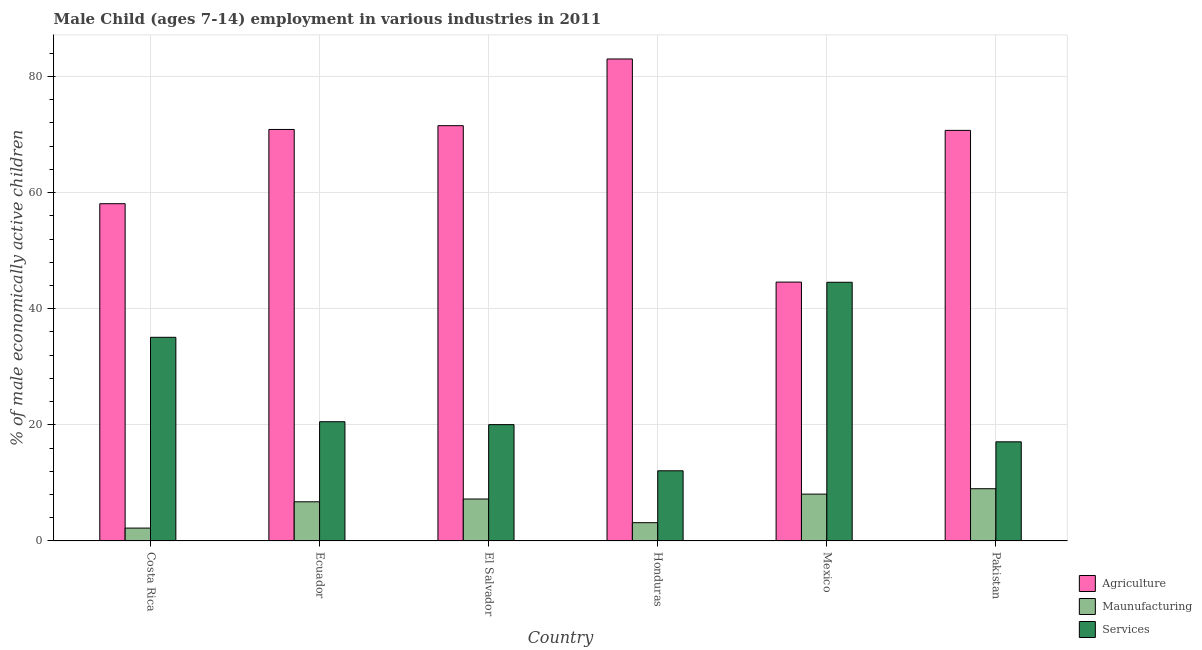How many different coloured bars are there?
Give a very brief answer. 3. How many groups of bars are there?
Your response must be concise. 6. Are the number of bars per tick equal to the number of legend labels?
Offer a terse response. Yes. How many bars are there on the 6th tick from the right?
Make the answer very short. 3. What is the label of the 5th group of bars from the left?
Your answer should be compact. Mexico. What is the percentage of economically active children in agriculture in Mexico?
Keep it short and to the point. 44.59. Across all countries, what is the maximum percentage of economically active children in agriculture?
Give a very brief answer. 83.02. Across all countries, what is the minimum percentage of economically active children in manufacturing?
Keep it short and to the point. 2.22. In which country was the percentage of economically active children in services minimum?
Offer a terse response. Honduras. What is the total percentage of economically active children in agriculture in the graph?
Your response must be concise. 398.83. What is the difference between the percentage of economically active children in agriculture in Honduras and that in Mexico?
Provide a succinct answer. 38.43. What is the difference between the percentage of economically active children in services in Costa Rica and the percentage of economically active children in agriculture in El Salvador?
Provide a short and direct response. -36.45. What is the average percentage of economically active children in agriculture per country?
Your response must be concise. 66.47. What is the difference between the percentage of economically active children in agriculture and percentage of economically active children in services in Mexico?
Give a very brief answer. 0.03. What is the ratio of the percentage of economically active children in agriculture in Ecuador to that in Pakistan?
Ensure brevity in your answer.  1. Is the percentage of economically active children in services in Ecuador less than that in Mexico?
Offer a very short reply. Yes. Is the difference between the percentage of economically active children in manufacturing in Ecuador and El Salvador greater than the difference between the percentage of economically active children in agriculture in Ecuador and El Salvador?
Make the answer very short. Yes. What is the difference between the highest and the second highest percentage of economically active children in agriculture?
Provide a short and direct response. 11.49. What is the difference between the highest and the lowest percentage of economically active children in services?
Your answer should be compact. 32.47. In how many countries, is the percentage of economically active children in agriculture greater than the average percentage of economically active children in agriculture taken over all countries?
Give a very brief answer. 4. Is the sum of the percentage of economically active children in services in Ecuador and Pakistan greater than the maximum percentage of economically active children in manufacturing across all countries?
Provide a short and direct response. Yes. What does the 2nd bar from the left in Ecuador represents?
Provide a succinct answer. Maunufacturing. What does the 1st bar from the right in Pakistan represents?
Your response must be concise. Services. Are all the bars in the graph horizontal?
Offer a very short reply. No. Are the values on the major ticks of Y-axis written in scientific E-notation?
Keep it short and to the point. No. Does the graph contain any zero values?
Offer a terse response. No. How are the legend labels stacked?
Provide a short and direct response. Vertical. What is the title of the graph?
Keep it short and to the point. Male Child (ages 7-14) employment in various industries in 2011. Does "Ages 0-14" appear as one of the legend labels in the graph?
Offer a very short reply. No. What is the label or title of the X-axis?
Your answer should be compact. Country. What is the label or title of the Y-axis?
Offer a very short reply. % of male economically active children. What is the % of male economically active children in Agriculture in Costa Rica?
Provide a short and direct response. 58.09. What is the % of male economically active children in Maunufacturing in Costa Rica?
Your answer should be compact. 2.22. What is the % of male economically active children of Services in Costa Rica?
Offer a terse response. 35.08. What is the % of male economically active children of Agriculture in Ecuador?
Offer a terse response. 70.88. What is the % of male economically active children of Maunufacturing in Ecuador?
Your response must be concise. 6.75. What is the % of male economically active children in Services in Ecuador?
Your answer should be very brief. 20.54. What is the % of male economically active children in Agriculture in El Salvador?
Your answer should be compact. 71.53. What is the % of male economically active children in Maunufacturing in El Salvador?
Make the answer very short. 7.23. What is the % of male economically active children in Services in El Salvador?
Ensure brevity in your answer.  20.04. What is the % of male economically active children of Agriculture in Honduras?
Provide a succinct answer. 83.02. What is the % of male economically active children of Maunufacturing in Honduras?
Ensure brevity in your answer.  3.15. What is the % of male economically active children of Services in Honduras?
Your response must be concise. 12.09. What is the % of male economically active children of Agriculture in Mexico?
Ensure brevity in your answer.  44.59. What is the % of male economically active children in Maunufacturing in Mexico?
Keep it short and to the point. 8.07. What is the % of male economically active children in Services in Mexico?
Make the answer very short. 44.56. What is the % of male economically active children in Agriculture in Pakistan?
Provide a short and direct response. 70.72. What is the % of male economically active children in Maunufacturing in Pakistan?
Provide a short and direct response. 9. What is the % of male economically active children of Services in Pakistan?
Your response must be concise. 17.08. Across all countries, what is the maximum % of male economically active children of Agriculture?
Make the answer very short. 83.02. Across all countries, what is the maximum % of male economically active children in Maunufacturing?
Your answer should be compact. 9. Across all countries, what is the maximum % of male economically active children in Services?
Your response must be concise. 44.56. Across all countries, what is the minimum % of male economically active children in Agriculture?
Provide a succinct answer. 44.59. Across all countries, what is the minimum % of male economically active children in Maunufacturing?
Offer a terse response. 2.22. Across all countries, what is the minimum % of male economically active children in Services?
Provide a succinct answer. 12.09. What is the total % of male economically active children of Agriculture in the graph?
Provide a short and direct response. 398.83. What is the total % of male economically active children of Maunufacturing in the graph?
Ensure brevity in your answer.  36.42. What is the total % of male economically active children in Services in the graph?
Give a very brief answer. 149.39. What is the difference between the % of male economically active children of Agriculture in Costa Rica and that in Ecuador?
Ensure brevity in your answer.  -12.79. What is the difference between the % of male economically active children in Maunufacturing in Costa Rica and that in Ecuador?
Make the answer very short. -4.53. What is the difference between the % of male economically active children of Services in Costa Rica and that in Ecuador?
Offer a very short reply. 14.54. What is the difference between the % of male economically active children of Agriculture in Costa Rica and that in El Salvador?
Make the answer very short. -13.44. What is the difference between the % of male economically active children of Maunufacturing in Costa Rica and that in El Salvador?
Offer a terse response. -5.01. What is the difference between the % of male economically active children in Services in Costa Rica and that in El Salvador?
Ensure brevity in your answer.  15.04. What is the difference between the % of male economically active children of Agriculture in Costa Rica and that in Honduras?
Your response must be concise. -24.93. What is the difference between the % of male economically active children in Maunufacturing in Costa Rica and that in Honduras?
Your response must be concise. -0.93. What is the difference between the % of male economically active children of Services in Costa Rica and that in Honduras?
Provide a succinct answer. 22.99. What is the difference between the % of male economically active children in Agriculture in Costa Rica and that in Mexico?
Your answer should be compact. 13.5. What is the difference between the % of male economically active children of Maunufacturing in Costa Rica and that in Mexico?
Offer a terse response. -5.85. What is the difference between the % of male economically active children in Services in Costa Rica and that in Mexico?
Give a very brief answer. -9.48. What is the difference between the % of male economically active children in Agriculture in Costa Rica and that in Pakistan?
Ensure brevity in your answer.  -12.63. What is the difference between the % of male economically active children of Maunufacturing in Costa Rica and that in Pakistan?
Your answer should be very brief. -6.78. What is the difference between the % of male economically active children in Services in Costa Rica and that in Pakistan?
Your answer should be compact. 18. What is the difference between the % of male economically active children of Agriculture in Ecuador and that in El Salvador?
Your answer should be compact. -0.65. What is the difference between the % of male economically active children of Maunufacturing in Ecuador and that in El Salvador?
Your response must be concise. -0.48. What is the difference between the % of male economically active children of Services in Ecuador and that in El Salvador?
Your response must be concise. 0.5. What is the difference between the % of male economically active children in Agriculture in Ecuador and that in Honduras?
Provide a short and direct response. -12.14. What is the difference between the % of male economically active children of Services in Ecuador and that in Honduras?
Your answer should be very brief. 8.45. What is the difference between the % of male economically active children of Agriculture in Ecuador and that in Mexico?
Make the answer very short. 26.29. What is the difference between the % of male economically active children of Maunufacturing in Ecuador and that in Mexico?
Keep it short and to the point. -1.32. What is the difference between the % of male economically active children in Services in Ecuador and that in Mexico?
Ensure brevity in your answer.  -24.02. What is the difference between the % of male economically active children in Agriculture in Ecuador and that in Pakistan?
Your response must be concise. 0.16. What is the difference between the % of male economically active children in Maunufacturing in Ecuador and that in Pakistan?
Provide a short and direct response. -2.25. What is the difference between the % of male economically active children in Services in Ecuador and that in Pakistan?
Offer a very short reply. 3.46. What is the difference between the % of male economically active children of Agriculture in El Salvador and that in Honduras?
Offer a very short reply. -11.49. What is the difference between the % of male economically active children of Maunufacturing in El Salvador and that in Honduras?
Your answer should be compact. 4.08. What is the difference between the % of male economically active children of Services in El Salvador and that in Honduras?
Offer a terse response. 7.95. What is the difference between the % of male economically active children of Agriculture in El Salvador and that in Mexico?
Give a very brief answer. 26.94. What is the difference between the % of male economically active children in Maunufacturing in El Salvador and that in Mexico?
Offer a terse response. -0.84. What is the difference between the % of male economically active children in Services in El Salvador and that in Mexico?
Make the answer very short. -24.52. What is the difference between the % of male economically active children of Agriculture in El Salvador and that in Pakistan?
Offer a terse response. 0.81. What is the difference between the % of male economically active children of Maunufacturing in El Salvador and that in Pakistan?
Your answer should be compact. -1.77. What is the difference between the % of male economically active children in Services in El Salvador and that in Pakistan?
Provide a short and direct response. 2.96. What is the difference between the % of male economically active children in Agriculture in Honduras and that in Mexico?
Your response must be concise. 38.43. What is the difference between the % of male economically active children of Maunufacturing in Honduras and that in Mexico?
Offer a terse response. -4.92. What is the difference between the % of male economically active children of Services in Honduras and that in Mexico?
Provide a succinct answer. -32.47. What is the difference between the % of male economically active children of Agriculture in Honduras and that in Pakistan?
Keep it short and to the point. 12.3. What is the difference between the % of male economically active children in Maunufacturing in Honduras and that in Pakistan?
Give a very brief answer. -5.85. What is the difference between the % of male economically active children of Services in Honduras and that in Pakistan?
Provide a succinct answer. -4.99. What is the difference between the % of male economically active children of Agriculture in Mexico and that in Pakistan?
Give a very brief answer. -26.13. What is the difference between the % of male economically active children in Maunufacturing in Mexico and that in Pakistan?
Offer a terse response. -0.93. What is the difference between the % of male economically active children of Services in Mexico and that in Pakistan?
Your answer should be very brief. 27.48. What is the difference between the % of male economically active children in Agriculture in Costa Rica and the % of male economically active children in Maunufacturing in Ecuador?
Your answer should be compact. 51.34. What is the difference between the % of male economically active children of Agriculture in Costa Rica and the % of male economically active children of Services in Ecuador?
Offer a very short reply. 37.55. What is the difference between the % of male economically active children of Maunufacturing in Costa Rica and the % of male economically active children of Services in Ecuador?
Ensure brevity in your answer.  -18.32. What is the difference between the % of male economically active children of Agriculture in Costa Rica and the % of male economically active children of Maunufacturing in El Salvador?
Provide a succinct answer. 50.86. What is the difference between the % of male economically active children of Agriculture in Costa Rica and the % of male economically active children of Services in El Salvador?
Give a very brief answer. 38.05. What is the difference between the % of male economically active children in Maunufacturing in Costa Rica and the % of male economically active children in Services in El Salvador?
Offer a terse response. -17.82. What is the difference between the % of male economically active children of Agriculture in Costa Rica and the % of male economically active children of Maunufacturing in Honduras?
Keep it short and to the point. 54.94. What is the difference between the % of male economically active children of Maunufacturing in Costa Rica and the % of male economically active children of Services in Honduras?
Make the answer very short. -9.87. What is the difference between the % of male economically active children in Agriculture in Costa Rica and the % of male economically active children in Maunufacturing in Mexico?
Keep it short and to the point. 50.02. What is the difference between the % of male economically active children of Agriculture in Costa Rica and the % of male economically active children of Services in Mexico?
Make the answer very short. 13.53. What is the difference between the % of male economically active children in Maunufacturing in Costa Rica and the % of male economically active children in Services in Mexico?
Offer a very short reply. -42.34. What is the difference between the % of male economically active children of Agriculture in Costa Rica and the % of male economically active children of Maunufacturing in Pakistan?
Your answer should be very brief. 49.09. What is the difference between the % of male economically active children of Agriculture in Costa Rica and the % of male economically active children of Services in Pakistan?
Your answer should be very brief. 41.01. What is the difference between the % of male economically active children of Maunufacturing in Costa Rica and the % of male economically active children of Services in Pakistan?
Offer a terse response. -14.86. What is the difference between the % of male economically active children in Agriculture in Ecuador and the % of male economically active children in Maunufacturing in El Salvador?
Make the answer very short. 63.65. What is the difference between the % of male economically active children of Agriculture in Ecuador and the % of male economically active children of Services in El Salvador?
Keep it short and to the point. 50.84. What is the difference between the % of male economically active children of Maunufacturing in Ecuador and the % of male economically active children of Services in El Salvador?
Provide a succinct answer. -13.29. What is the difference between the % of male economically active children of Agriculture in Ecuador and the % of male economically active children of Maunufacturing in Honduras?
Keep it short and to the point. 67.73. What is the difference between the % of male economically active children of Agriculture in Ecuador and the % of male economically active children of Services in Honduras?
Provide a short and direct response. 58.79. What is the difference between the % of male economically active children in Maunufacturing in Ecuador and the % of male economically active children in Services in Honduras?
Offer a very short reply. -5.34. What is the difference between the % of male economically active children of Agriculture in Ecuador and the % of male economically active children of Maunufacturing in Mexico?
Give a very brief answer. 62.81. What is the difference between the % of male economically active children of Agriculture in Ecuador and the % of male economically active children of Services in Mexico?
Offer a terse response. 26.32. What is the difference between the % of male economically active children of Maunufacturing in Ecuador and the % of male economically active children of Services in Mexico?
Give a very brief answer. -37.81. What is the difference between the % of male economically active children in Agriculture in Ecuador and the % of male economically active children in Maunufacturing in Pakistan?
Offer a very short reply. 61.88. What is the difference between the % of male economically active children of Agriculture in Ecuador and the % of male economically active children of Services in Pakistan?
Your answer should be compact. 53.8. What is the difference between the % of male economically active children in Maunufacturing in Ecuador and the % of male economically active children in Services in Pakistan?
Give a very brief answer. -10.33. What is the difference between the % of male economically active children in Agriculture in El Salvador and the % of male economically active children in Maunufacturing in Honduras?
Provide a succinct answer. 68.38. What is the difference between the % of male economically active children in Agriculture in El Salvador and the % of male economically active children in Services in Honduras?
Your answer should be very brief. 59.44. What is the difference between the % of male economically active children of Maunufacturing in El Salvador and the % of male economically active children of Services in Honduras?
Give a very brief answer. -4.86. What is the difference between the % of male economically active children of Agriculture in El Salvador and the % of male economically active children of Maunufacturing in Mexico?
Make the answer very short. 63.46. What is the difference between the % of male economically active children of Agriculture in El Salvador and the % of male economically active children of Services in Mexico?
Offer a very short reply. 26.97. What is the difference between the % of male economically active children of Maunufacturing in El Salvador and the % of male economically active children of Services in Mexico?
Ensure brevity in your answer.  -37.33. What is the difference between the % of male economically active children in Agriculture in El Salvador and the % of male economically active children in Maunufacturing in Pakistan?
Keep it short and to the point. 62.53. What is the difference between the % of male economically active children in Agriculture in El Salvador and the % of male economically active children in Services in Pakistan?
Provide a short and direct response. 54.45. What is the difference between the % of male economically active children of Maunufacturing in El Salvador and the % of male economically active children of Services in Pakistan?
Provide a succinct answer. -9.85. What is the difference between the % of male economically active children in Agriculture in Honduras and the % of male economically active children in Maunufacturing in Mexico?
Your answer should be compact. 74.95. What is the difference between the % of male economically active children of Agriculture in Honduras and the % of male economically active children of Services in Mexico?
Provide a succinct answer. 38.46. What is the difference between the % of male economically active children of Maunufacturing in Honduras and the % of male economically active children of Services in Mexico?
Your answer should be compact. -41.41. What is the difference between the % of male economically active children of Agriculture in Honduras and the % of male economically active children of Maunufacturing in Pakistan?
Offer a terse response. 74.02. What is the difference between the % of male economically active children of Agriculture in Honduras and the % of male economically active children of Services in Pakistan?
Ensure brevity in your answer.  65.94. What is the difference between the % of male economically active children of Maunufacturing in Honduras and the % of male economically active children of Services in Pakistan?
Offer a very short reply. -13.93. What is the difference between the % of male economically active children in Agriculture in Mexico and the % of male economically active children in Maunufacturing in Pakistan?
Your answer should be very brief. 35.59. What is the difference between the % of male economically active children in Agriculture in Mexico and the % of male economically active children in Services in Pakistan?
Make the answer very short. 27.51. What is the difference between the % of male economically active children in Maunufacturing in Mexico and the % of male economically active children in Services in Pakistan?
Provide a succinct answer. -9.01. What is the average % of male economically active children in Agriculture per country?
Keep it short and to the point. 66.47. What is the average % of male economically active children of Maunufacturing per country?
Ensure brevity in your answer.  6.07. What is the average % of male economically active children in Services per country?
Give a very brief answer. 24.9. What is the difference between the % of male economically active children of Agriculture and % of male economically active children of Maunufacturing in Costa Rica?
Your response must be concise. 55.87. What is the difference between the % of male economically active children of Agriculture and % of male economically active children of Services in Costa Rica?
Ensure brevity in your answer.  23.01. What is the difference between the % of male economically active children in Maunufacturing and % of male economically active children in Services in Costa Rica?
Offer a terse response. -32.86. What is the difference between the % of male economically active children in Agriculture and % of male economically active children in Maunufacturing in Ecuador?
Make the answer very short. 64.13. What is the difference between the % of male economically active children in Agriculture and % of male economically active children in Services in Ecuador?
Offer a very short reply. 50.34. What is the difference between the % of male economically active children in Maunufacturing and % of male economically active children in Services in Ecuador?
Ensure brevity in your answer.  -13.79. What is the difference between the % of male economically active children in Agriculture and % of male economically active children in Maunufacturing in El Salvador?
Your answer should be compact. 64.3. What is the difference between the % of male economically active children of Agriculture and % of male economically active children of Services in El Salvador?
Provide a succinct answer. 51.49. What is the difference between the % of male economically active children of Maunufacturing and % of male economically active children of Services in El Salvador?
Your answer should be compact. -12.81. What is the difference between the % of male economically active children in Agriculture and % of male economically active children in Maunufacturing in Honduras?
Give a very brief answer. 79.87. What is the difference between the % of male economically active children of Agriculture and % of male economically active children of Services in Honduras?
Offer a terse response. 70.93. What is the difference between the % of male economically active children in Maunufacturing and % of male economically active children in Services in Honduras?
Offer a very short reply. -8.94. What is the difference between the % of male economically active children in Agriculture and % of male economically active children in Maunufacturing in Mexico?
Your answer should be very brief. 36.52. What is the difference between the % of male economically active children of Agriculture and % of male economically active children of Services in Mexico?
Keep it short and to the point. 0.03. What is the difference between the % of male economically active children in Maunufacturing and % of male economically active children in Services in Mexico?
Offer a terse response. -36.49. What is the difference between the % of male economically active children in Agriculture and % of male economically active children in Maunufacturing in Pakistan?
Make the answer very short. 61.72. What is the difference between the % of male economically active children in Agriculture and % of male economically active children in Services in Pakistan?
Offer a terse response. 53.64. What is the difference between the % of male economically active children of Maunufacturing and % of male economically active children of Services in Pakistan?
Keep it short and to the point. -8.08. What is the ratio of the % of male economically active children in Agriculture in Costa Rica to that in Ecuador?
Give a very brief answer. 0.82. What is the ratio of the % of male economically active children in Maunufacturing in Costa Rica to that in Ecuador?
Offer a terse response. 0.33. What is the ratio of the % of male economically active children of Services in Costa Rica to that in Ecuador?
Offer a very short reply. 1.71. What is the ratio of the % of male economically active children of Agriculture in Costa Rica to that in El Salvador?
Your answer should be very brief. 0.81. What is the ratio of the % of male economically active children of Maunufacturing in Costa Rica to that in El Salvador?
Make the answer very short. 0.31. What is the ratio of the % of male economically active children in Services in Costa Rica to that in El Salvador?
Offer a terse response. 1.75. What is the ratio of the % of male economically active children in Agriculture in Costa Rica to that in Honduras?
Keep it short and to the point. 0.7. What is the ratio of the % of male economically active children in Maunufacturing in Costa Rica to that in Honduras?
Offer a very short reply. 0.7. What is the ratio of the % of male economically active children in Services in Costa Rica to that in Honduras?
Provide a succinct answer. 2.9. What is the ratio of the % of male economically active children in Agriculture in Costa Rica to that in Mexico?
Provide a short and direct response. 1.3. What is the ratio of the % of male economically active children in Maunufacturing in Costa Rica to that in Mexico?
Provide a short and direct response. 0.28. What is the ratio of the % of male economically active children of Services in Costa Rica to that in Mexico?
Keep it short and to the point. 0.79. What is the ratio of the % of male economically active children of Agriculture in Costa Rica to that in Pakistan?
Your answer should be compact. 0.82. What is the ratio of the % of male economically active children of Maunufacturing in Costa Rica to that in Pakistan?
Provide a short and direct response. 0.25. What is the ratio of the % of male economically active children of Services in Costa Rica to that in Pakistan?
Provide a succinct answer. 2.05. What is the ratio of the % of male economically active children of Agriculture in Ecuador to that in El Salvador?
Give a very brief answer. 0.99. What is the ratio of the % of male economically active children in Maunufacturing in Ecuador to that in El Salvador?
Your answer should be compact. 0.93. What is the ratio of the % of male economically active children of Services in Ecuador to that in El Salvador?
Offer a very short reply. 1.02. What is the ratio of the % of male economically active children of Agriculture in Ecuador to that in Honduras?
Offer a terse response. 0.85. What is the ratio of the % of male economically active children in Maunufacturing in Ecuador to that in Honduras?
Ensure brevity in your answer.  2.14. What is the ratio of the % of male economically active children in Services in Ecuador to that in Honduras?
Offer a very short reply. 1.7. What is the ratio of the % of male economically active children of Agriculture in Ecuador to that in Mexico?
Keep it short and to the point. 1.59. What is the ratio of the % of male economically active children in Maunufacturing in Ecuador to that in Mexico?
Give a very brief answer. 0.84. What is the ratio of the % of male economically active children of Services in Ecuador to that in Mexico?
Keep it short and to the point. 0.46. What is the ratio of the % of male economically active children in Agriculture in Ecuador to that in Pakistan?
Your answer should be compact. 1. What is the ratio of the % of male economically active children of Maunufacturing in Ecuador to that in Pakistan?
Your answer should be compact. 0.75. What is the ratio of the % of male economically active children in Services in Ecuador to that in Pakistan?
Provide a short and direct response. 1.2. What is the ratio of the % of male economically active children of Agriculture in El Salvador to that in Honduras?
Provide a short and direct response. 0.86. What is the ratio of the % of male economically active children in Maunufacturing in El Salvador to that in Honduras?
Keep it short and to the point. 2.3. What is the ratio of the % of male economically active children in Services in El Salvador to that in Honduras?
Your answer should be very brief. 1.66. What is the ratio of the % of male economically active children in Agriculture in El Salvador to that in Mexico?
Offer a terse response. 1.6. What is the ratio of the % of male economically active children in Maunufacturing in El Salvador to that in Mexico?
Provide a short and direct response. 0.9. What is the ratio of the % of male economically active children of Services in El Salvador to that in Mexico?
Give a very brief answer. 0.45. What is the ratio of the % of male economically active children of Agriculture in El Salvador to that in Pakistan?
Offer a terse response. 1.01. What is the ratio of the % of male economically active children of Maunufacturing in El Salvador to that in Pakistan?
Provide a short and direct response. 0.8. What is the ratio of the % of male economically active children in Services in El Salvador to that in Pakistan?
Keep it short and to the point. 1.17. What is the ratio of the % of male economically active children of Agriculture in Honduras to that in Mexico?
Your response must be concise. 1.86. What is the ratio of the % of male economically active children in Maunufacturing in Honduras to that in Mexico?
Make the answer very short. 0.39. What is the ratio of the % of male economically active children in Services in Honduras to that in Mexico?
Offer a very short reply. 0.27. What is the ratio of the % of male economically active children of Agriculture in Honduras to that in Pakistan?
Your answer should be very brief. 1.17. What is the ratio of the % of male economically active children in Maunufacturing in Honduras to that in Pakistan?
Ensure brevity in your answer.  0.35. What is the ratio of the % of male economically active children in Services in Honduras to that in Pakistan?
Keep it short and to the point. 0.71. What is the ratio of the % of male economically active children in Agriculture in Mexico to that in Pakistan?
Your answer should be compact. 0.63. What is the ratio of the % of male economically active children in Maunufacturing in Mexico to that in Pakistan?
Your response must be concise. 0.9. What is the ratio of the % of male economically active children of Services in Mexico to that in Pakistan?
Make the answer very short. 2.61. What is the difference between the highest and the second highest % of male economically active children in Agriculture?
Provide a short and direct response. 11.49. What is the difference between the highest and the second highest % of male economically active children of Maunufacturing?
Offer a very short reply. 0.93. What is the difference between the highest and the second highest % of male economically active children in Services?
Give a very brief answer. 9.48. What is the difference between the highest and the lowest % of male economically active children in Agriculture?
Ensure brevity in your answer.  38.43. What is the difference between the highest and the lowest % of male economically active children in Maunufacturing?
Your response must be concise. 6.78. What is the difference between the highest and the lowest % of male economically active children of Services?
Make the answer very short. 32.47. 